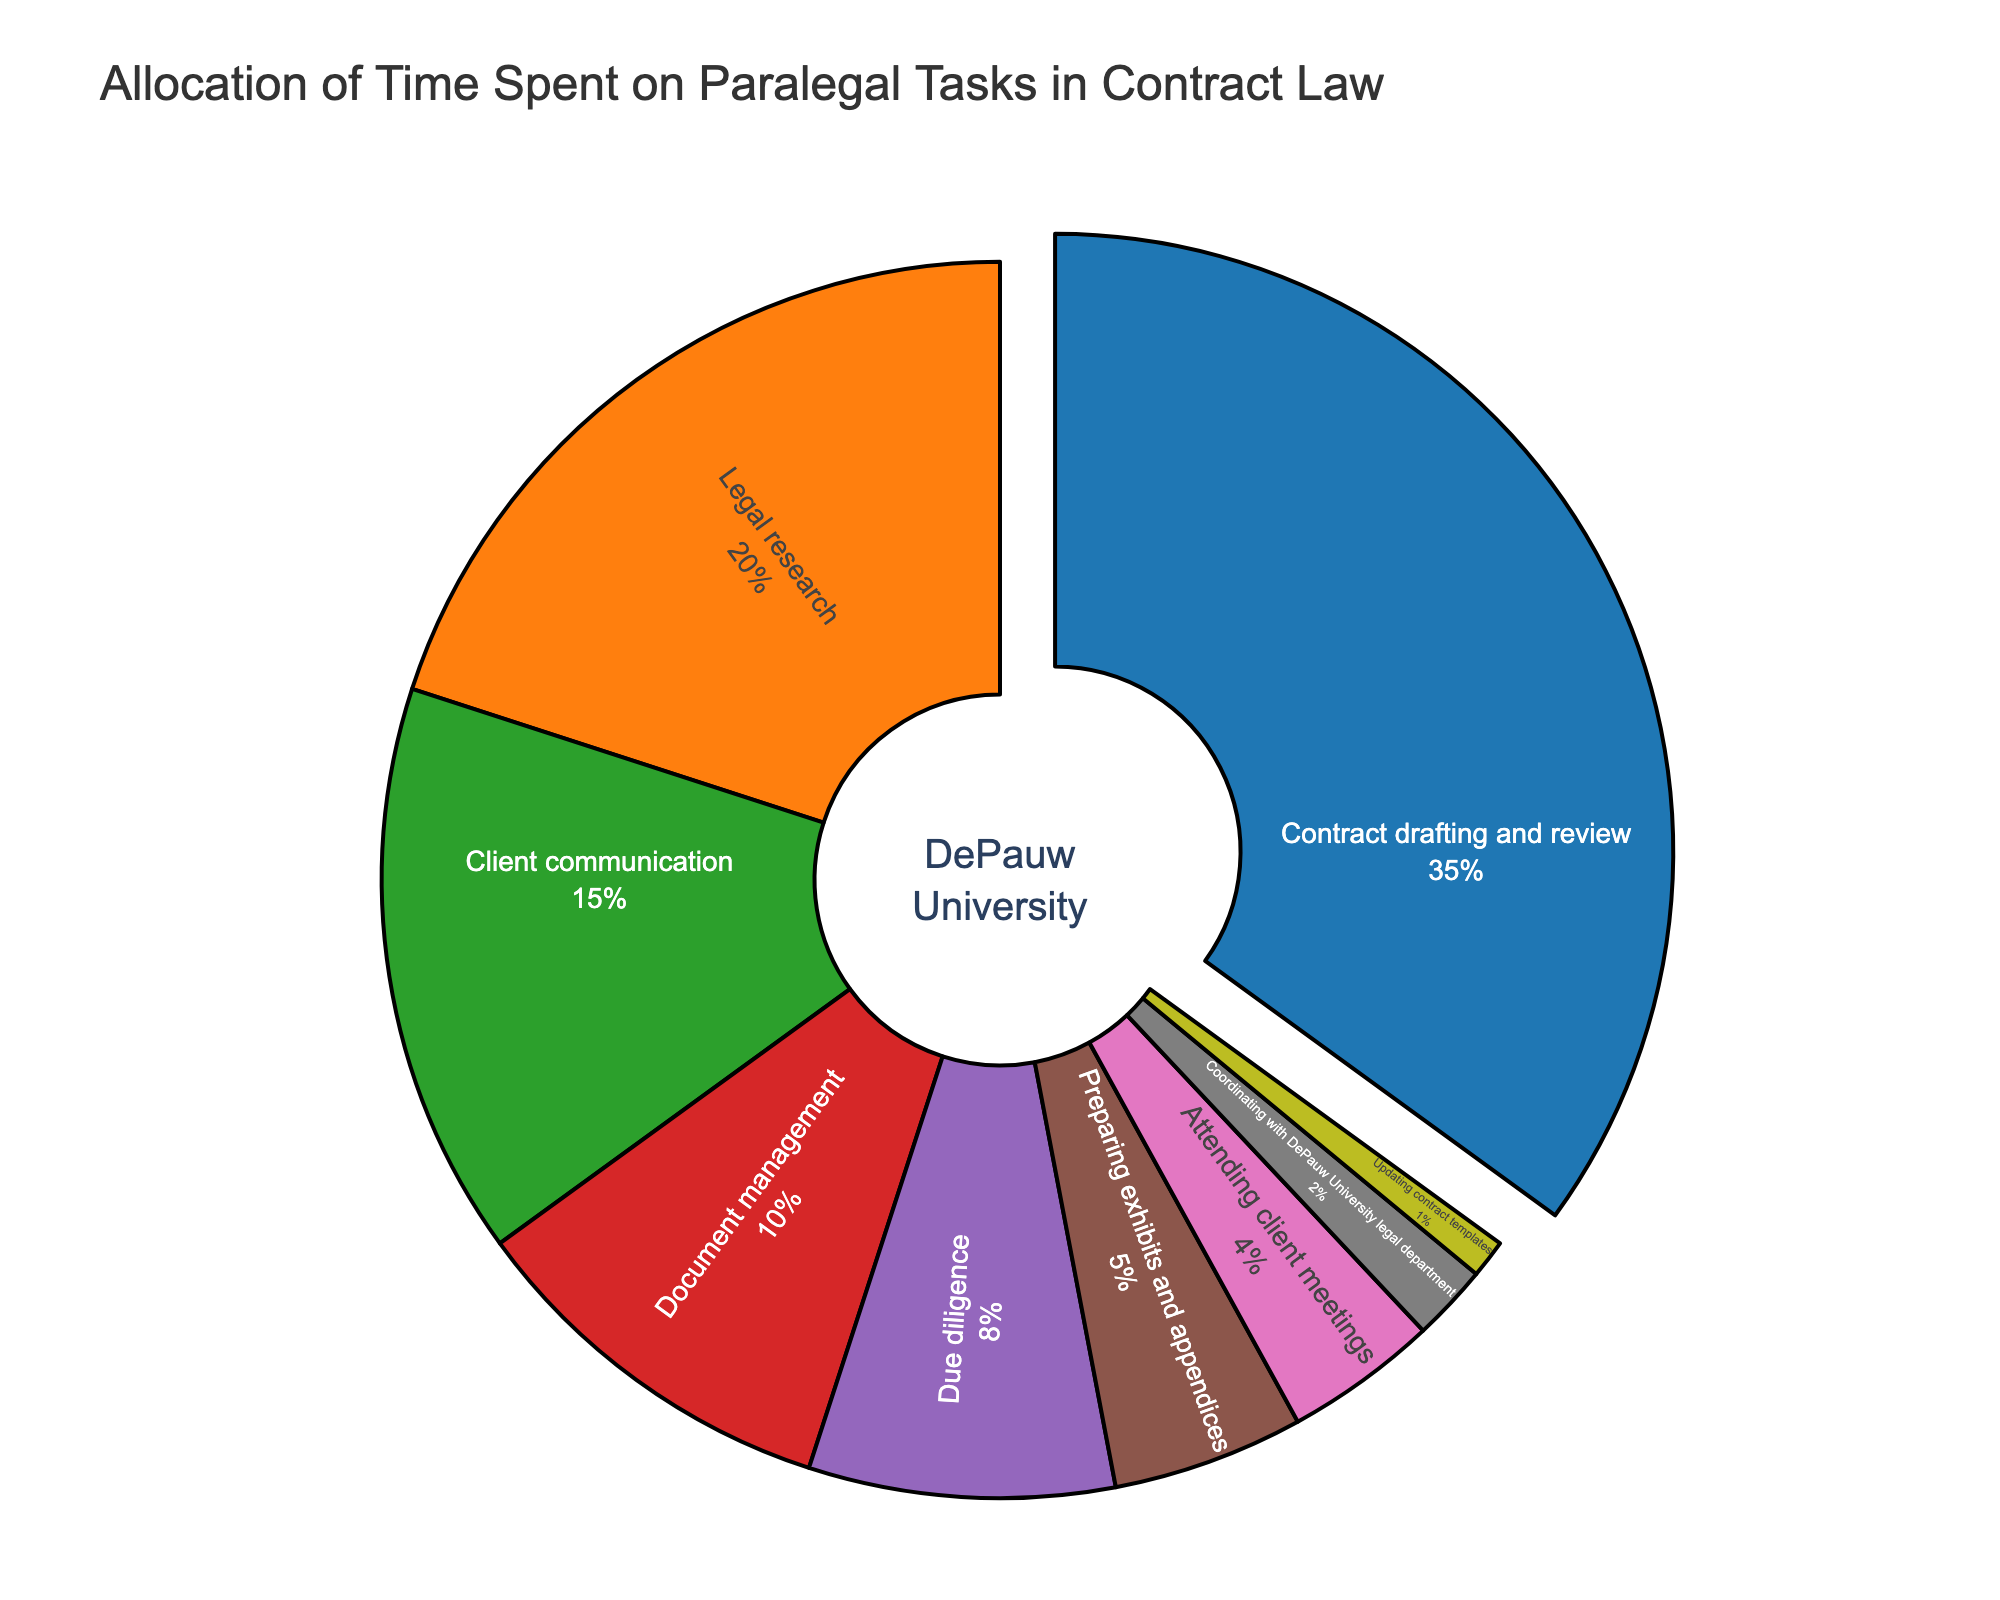What's the most time-consuming task for a paralegal in contract law according to the pie chart? Look at the segment with the largest percentage. The "Contract drafting and review" segment has the largest share at 35%.
Answer: Contract drafting and review Which task is least time-consuming according to the pie chart? Look at the segment with the smallest percentage. The "Updating contract templates" segment has the smallest share at 1%.
Answer: Updating contract templates How much more time is spent on legal research compared to attending client meetings? Subtract the percentage of time spent on attending client meetings from that spent on legal research: 20% - 4% = 16%.
Answer: 16% What is the combined percentage of time spent on document management and due diligence? Sum the percentages of time spent on document management and due diligence: 10% + 8% = 18%.
Answer: 18% Which tasks together comprise exactly half of the total time spent? Look for tasks that add up to 50%. "Contract drafting and review" (35%) and "Legal research" (20%) together make 55%, but "Contract drafting and review" (35%) plus "Client communication" (15%) together make exactly 50%.
Answer: Contract drafting and review and Client communication Are there more tasks that individually take up less than 10% of the time or more than 10% of the time? Count the number of tasks in each category. Less than 10%: Due diligence, preparing exhibits and appendices, attending client meetings, coordinating with DePauw University legal department, and updating contract templates (5 tasks). More than 10%: Contract drafting and review, legal research, client communication, and document management (4 tasks).
Answer: Less than 10% Which colored segment in the pie chart represents client communication tasks? Identify the color corresponding to "Client communication". Based on the provided colors list, it's the fourth segment which is typically the fourth color in the sequence (often orange, blue, green, red, etc depending on given colors). In the provided list, it appears likely to be the third color.
Answer: Green (assuming order follows the list) What's the total percentage of time spent on tasks other than contract drafting and review? Subtract the percentage of time spent on contract drafting and review from 100%: 100% - 35% = 65%.
Answer: 65% Which task's percentage is nearest to the average percentage of all tasks? Calculate the average by summing all percentages and dividing by the number of tasks: (35 + 20 + 15 + 10 + 8 + 5 + 4 + 2 + 1) / 9 = 100% / 9 ≈ 11.11%. The closest percentage to 11.11% is 10% for document management.
Answer: Document management What's the difference in time percentage between the most and least time-consuming tasks? Subtract the percentage of the least time-consuming task (1%) from the most time-consuming task (35%): 35% - 1% = 34%.
Answer: 34% 